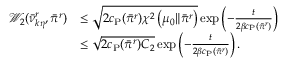<formula> <loc_0><loc_0><loc_500><loc_500>\begin{array} { r l } { \mathcal { W } _ { 2 } ( \ B a r { \nu } _ { k \eta } ^ { r } , \ B a r { \pi } ^ { r } ) } & { \leq \sqrt { 2 c _ { P } ( \ B a r { \pi } ^ { r } ) \chi ^ { 2 } \left ( \mu _ { 0 } \| \ B a r { \pi } ^ { r } \right ) } \exp \left ( - \frac { t } { 2 \beta c _ { P } ( \ B a r { \pi } ^ { r } ) } \right ) } \\ & { \leq \sqrt { 2 c _ { P } ( \ B a r { \pi } ^ { r } ) C _ { 2 } } \exp \left ( - \frac { t } { 2 \beta c _ { P } ( \ B a r { \pi } ^ { r } ) } \right ) . } \end{array}</formula> 